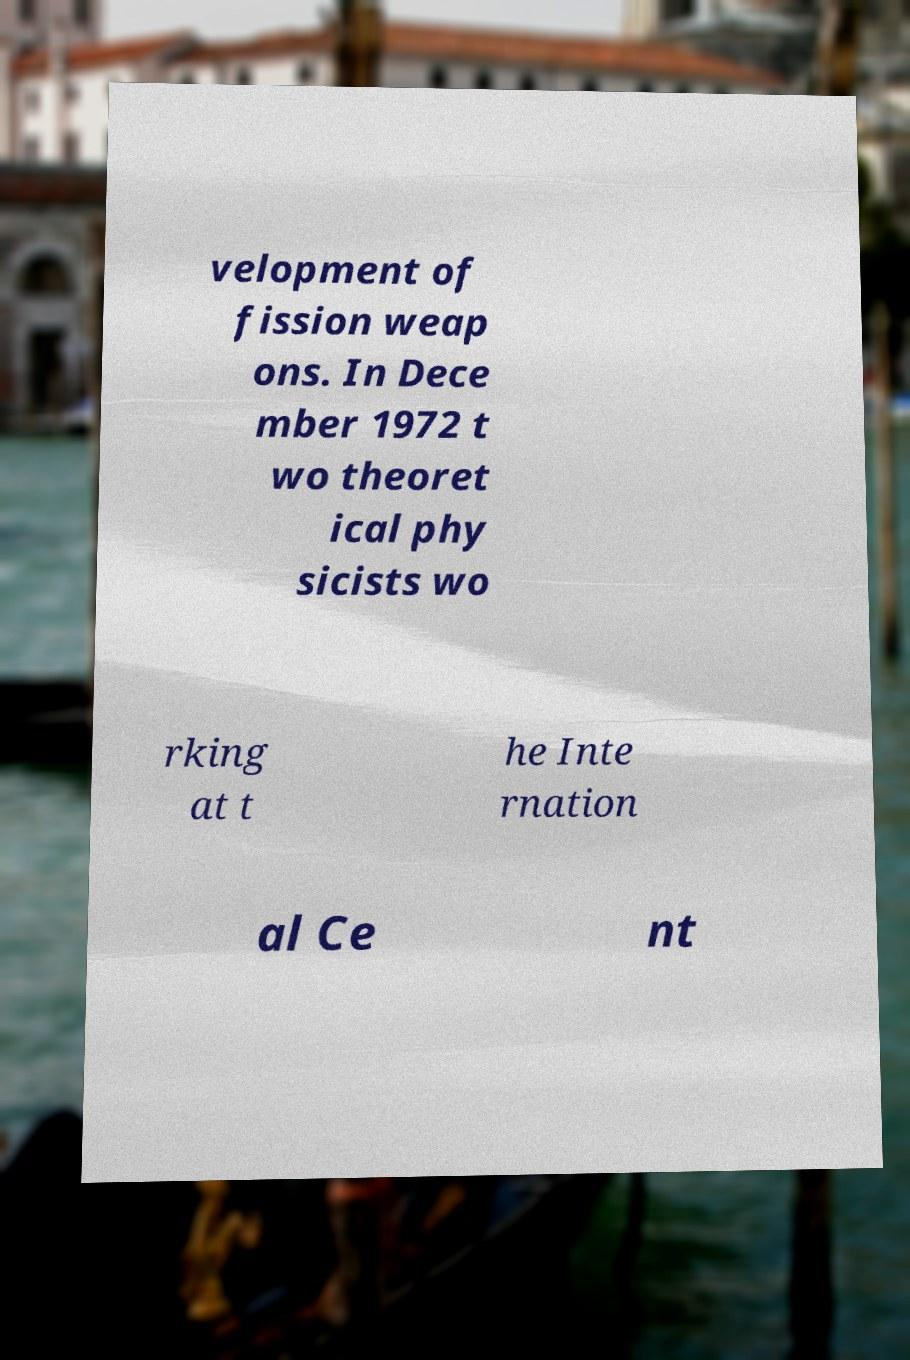For documentation purposes, I need the text within this image transcribed. Could you provide that? velopment of fission weap ons. In Dece mber 1972 t wo theoret ical phy sicists wo rking at t he Inte rnation al Ce nt 